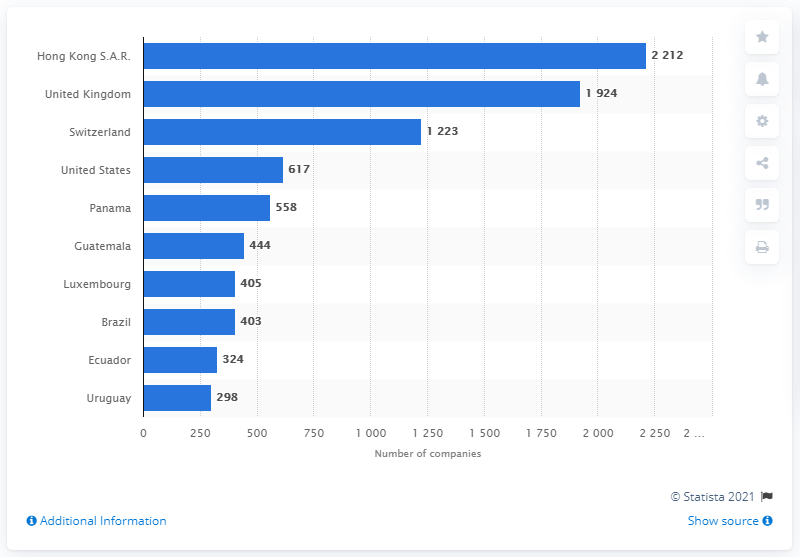Point out several critical features in this image. Mossack Fonseca is headquartered in Panama. 